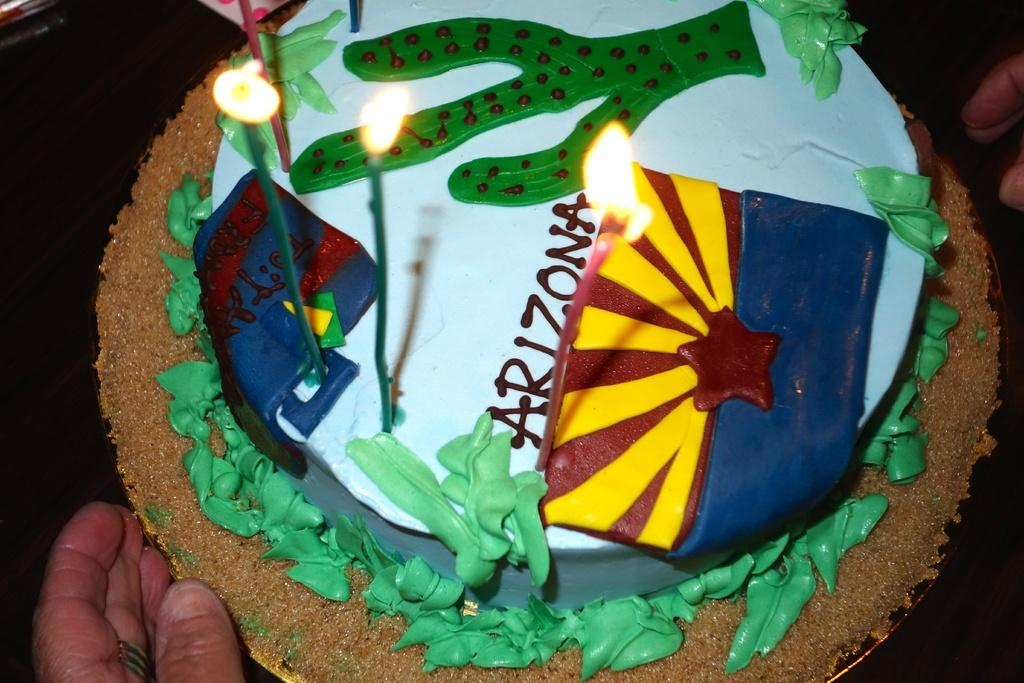What is the main subject of the image? There is a cake in the image. What is placed on top of the cake? There are candles on the cake. Whose hand can be seen in the image? A human hand is visible at the bottom of the image. What is the color of the background in the image? The background of the image is black in color. Can you tell me how many snails are crawling on the cake in the image? There are no snails present on the cake in the image. What type of pancake is being served to the partner in the image? There is no partner or pancake present in the image; it features a cake with candles and a human hand. 